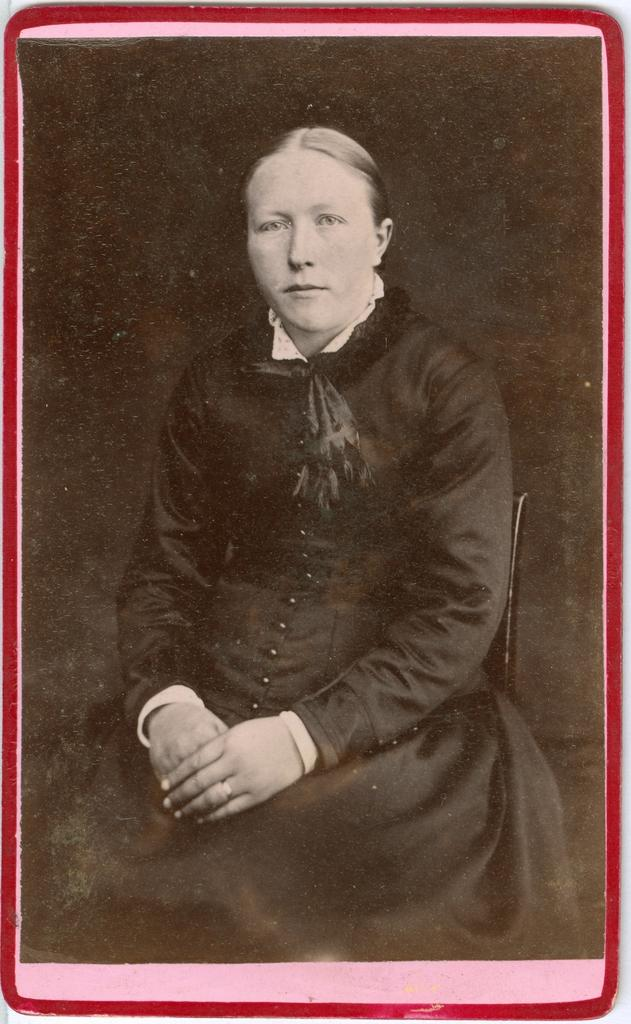What type of object is the main subject of the image? The image is a photo frame. Who or what is depicted in the photo frame? There is a person in the photo frame. What is the color or tone of the background in the photo frame? The background of the photo frame is dark. How many eggs are visible in the photo frame? There are no eggs present in the photo frame; it contains a picture of a person. What type of wax is used to create the person's facial features in the photo frame? There is no wax used in the photo frame; it is a photograph of a person. 